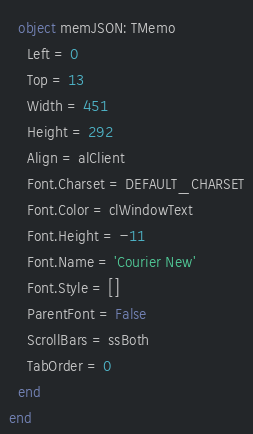Convert code to text. <code><loc_0><loc_0><loc_500><loc_500><_Pascal_>  object memJSON: TMemo
    Left = 0
    Top = 13
    Width = 451
    Height = 292
    Align = alClient
    Font.Charset = DEFAULT_CHARSET
    Font.Color = clWindowText
    Font.Height = -11
    Font.Name = 'Courier New'
    Font.Style = []
    ParentFont = False
    ScrollBars = ssBoth
    TabOrder = 0
  end
end
</code> 